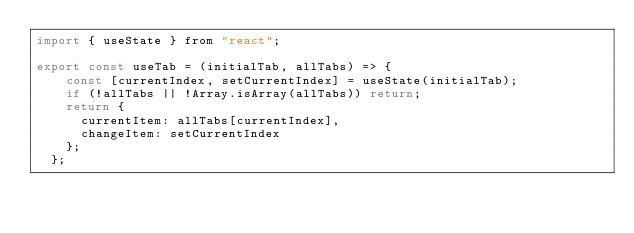<code> <loc_0><loc_0><loc_500><loc_500><_JavaScript_>import { useState } from "react";

export const useTab = (initialTab, allTabs) => {
    const [currentIndex, setCurrentIndex] = useState(initialTab);
    if (!allTabs || !Array.isArray(allTabs)) return;
    return {
      currentItem: allTabs[currentIndex],
      changeItem: setCurrentIndex
    };
  };</code> 